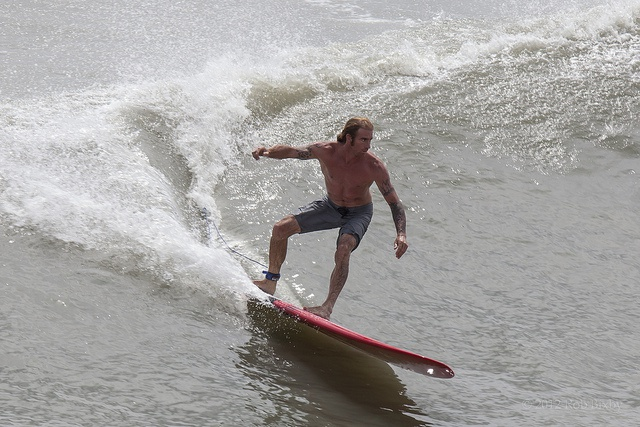Describe the objects in this image and their specific colors. I can see people in darkgray, maroon, gray, and black tones and surfboard in darkgray, maroon, black, gray, and lightpink tones in this image. 